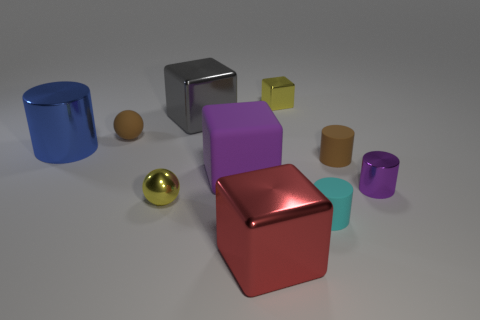Subtract all yellow cubes. How many cubes are left? 3 Subtract all purple cylinders. How many cylinders are left? 3 Subtract 3 cylinders. How many cylinders are left? 1 Subtract all spheres. How many objects are left? 8 Subtract all tiny red shiny blocks. Subtract all red objects. How many objects are left? 9 Add 3 matte things. How many matte things are left? 7 Add 2 large shiny objects. How many large shiny objects exist? 5 Subtract 1 red cubes. How many objects are left? 9 Subtract all brown cylinders. Subtract all green cubes. How many cylinders are left? 3 